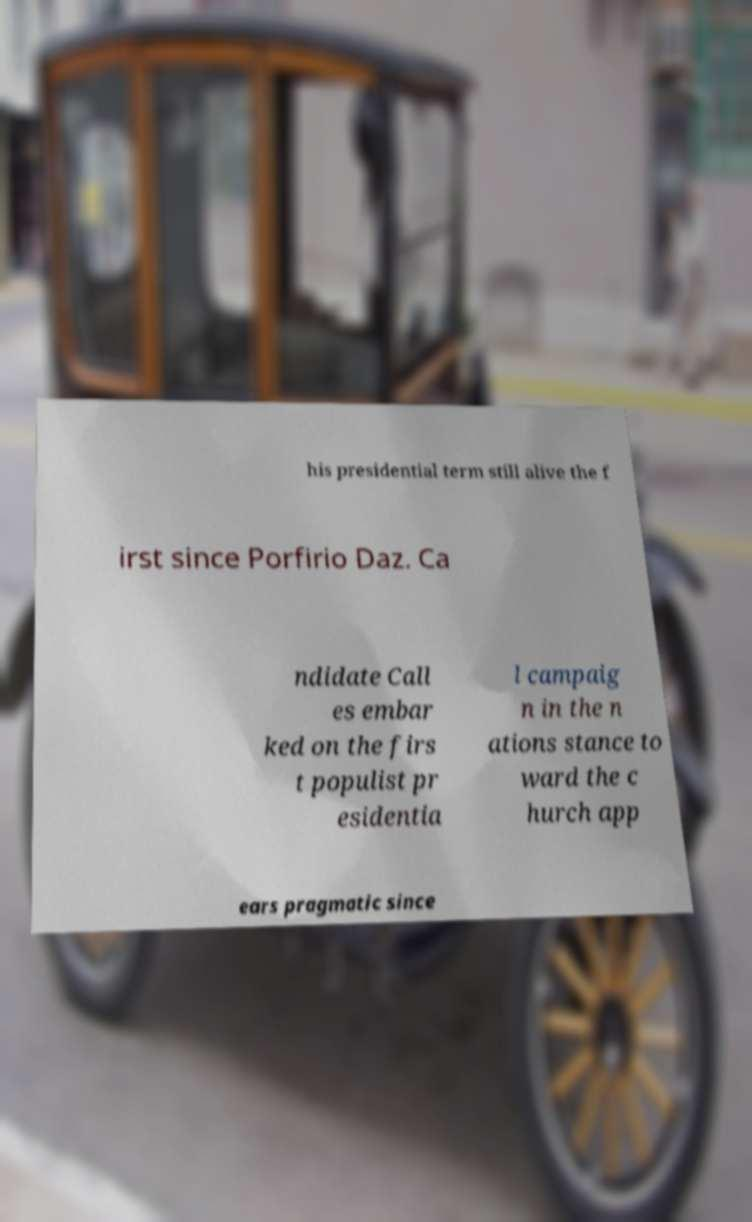What messages or text are displayed in this image? I need them in a readable, typed format. his presidential term still alive the f irst since Porfirio Daz. Ca ndidate Call es embar ked on the firs t populist pr esidentia l campaig n in the n ations stance to ward the c hurch app ears pragmatic since 